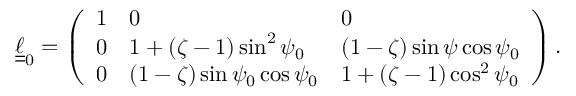Convert formula to latex. <formula><loc_0><loc_0><loc_500><loc_500>\underline { { \underline { \ell } } } _ { 0 } = \left ( \begin{array} { l l l } { 1 } & { 0 } & { 0 } \\ { 0 } & { 1 + ( \zeta - 1 ) \sin ^ { 2 } \psi _ { 0 } } & { ( 1 - \zeta ) \sin \psi \cos \psi _ { 0 } } \\ { 0 } & { ( 1 - \zeta ) \sin \psi _ { 0 } \cos \psi _ { 0 } } & { 1 + ( \zeta - 1 ) \cos ^ { 2 } \psi _ { 0 } } \end{array} \right ) .</formula> 